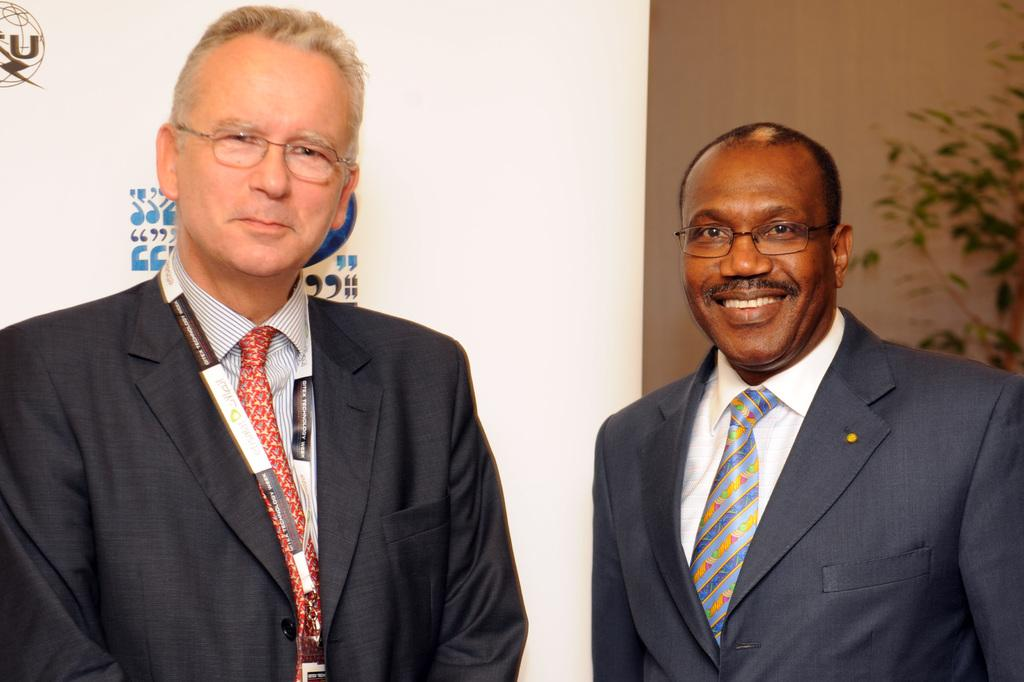How many people are in the image? There are two persons in the image. What are the persons wearing? The persons are wearing blazers. What can be seen on the right side of the image? There is a plant on the right side of the image. How many locks can be seen on the desk in the image? There is no desk present in the image, so it is not possible to determine the number of locks. 